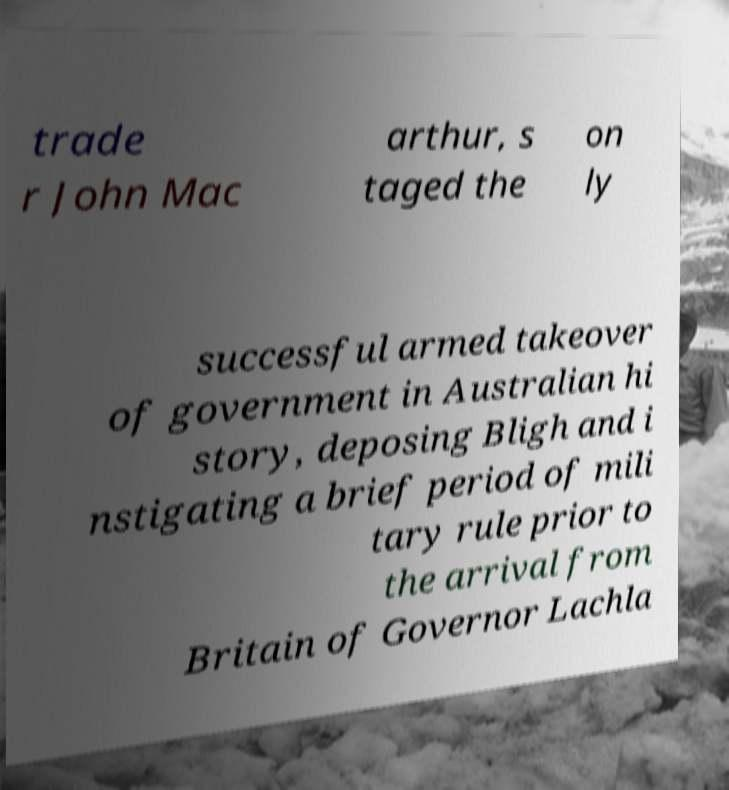I need the written content from this picture converted into text. Can you do that? trade r John Mac arthur, s taged the on ly successful armed takeover of government in Australian hi story, deposing Bligh and i nstigating a brief period of mili tary rule prior to the arrival from Britain of Governor Lachla 